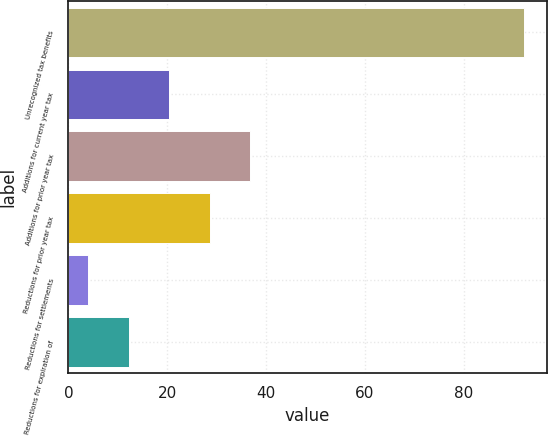Convert chart to OTSL. <chart><loc_0><loc_0><loc_500><loc_500><bar_chart><fcel>Unrecognized tax benefits<fcel>Additions for current year tax<fcel>Additions for prior year tax<fcel>Reductions for prior year tax<fcel>Reductions for settlements<fcel>Reductions for expiration of<nl><fcel>92.2<fcel>20.4<fcel>36.8<fcel>28.6<fcel>4<fcel>12.2<nl></chart> 